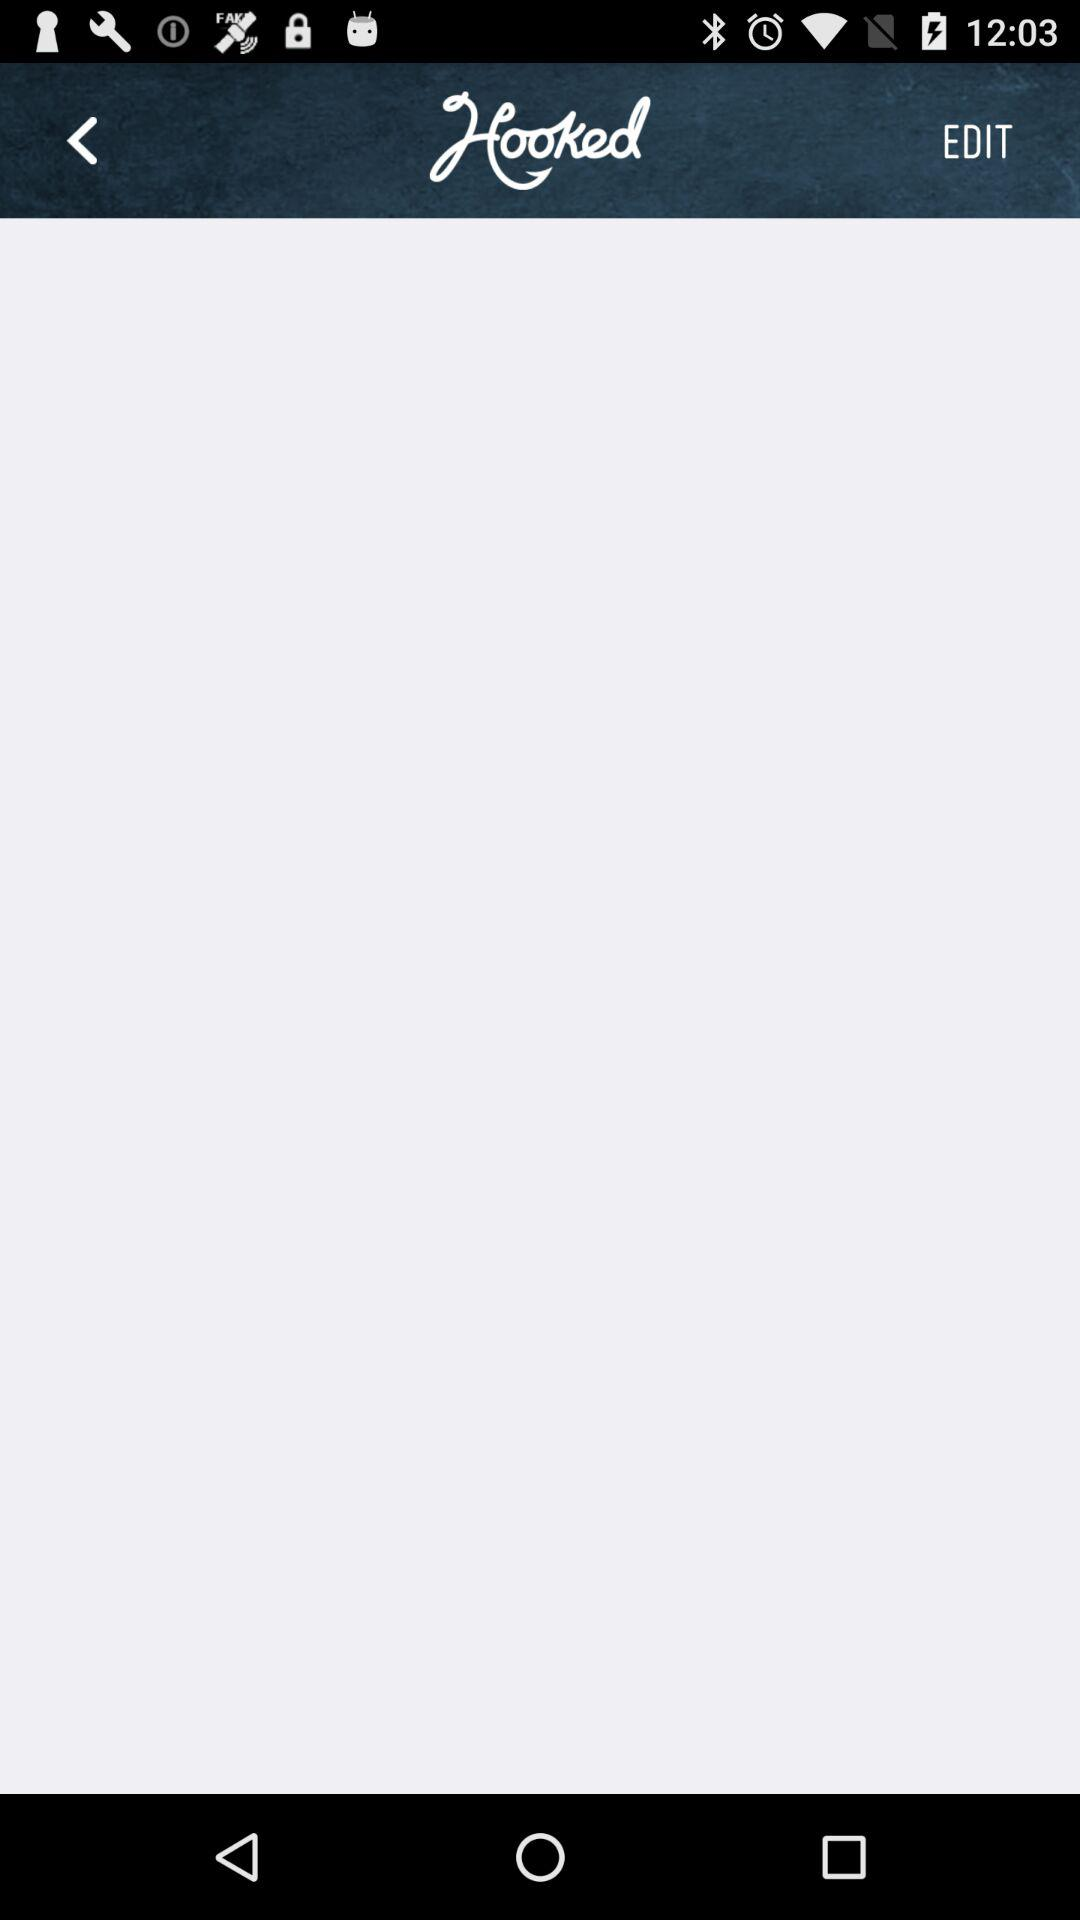Who is this application powered by?
When the provided information is insufficient, respond with <no answer>. <no answer> 